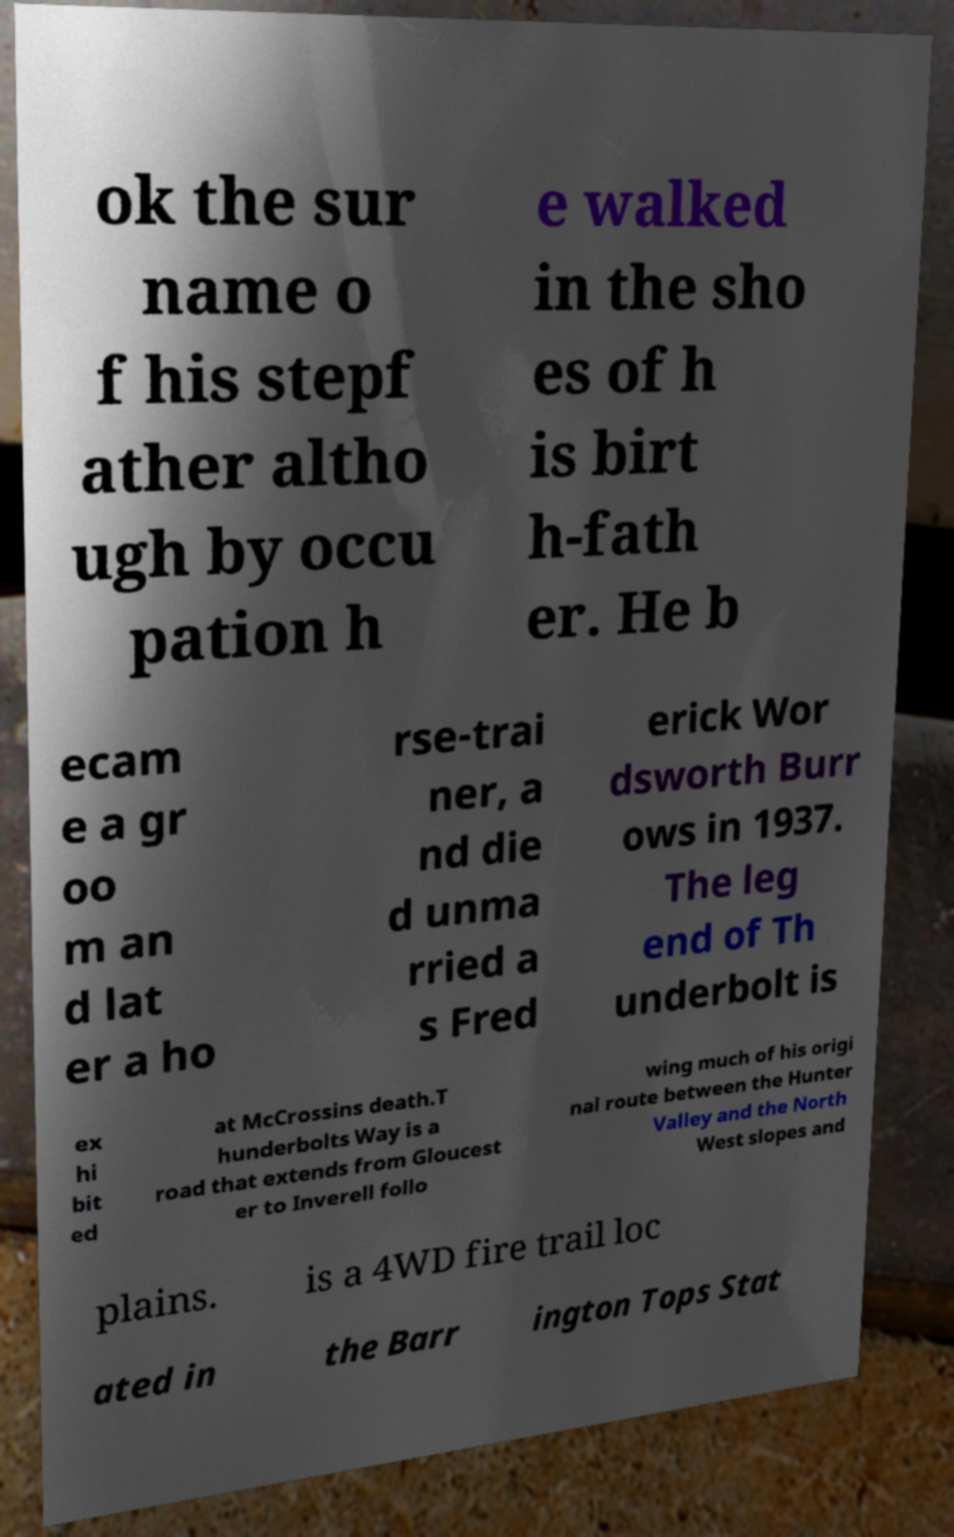Can you read and provide the text displayed in the image?This photo seems to have some interesting text. Can you extract and type it out for me? ok the sur name o f his stepf ather altho ugh by occu pation h e walked in the sho es of h is birt h-fath er. He b ecam e a gr oo m an d lat er a ho rse-trai ner, a nd die d unma rried a s Fred erick Wor dsworth Burr ows in 1937. The leg end of Th underbolt is ex hi bit ed at McCrossins death.T hunderbolts Way is a road that extends from Gloucest er to Inverell follo wing much of his origi nal route between the Hunter Valley and the North West slopes and plains. is a 4WD fire trail loc ated in the Barr ington Tops Stat 